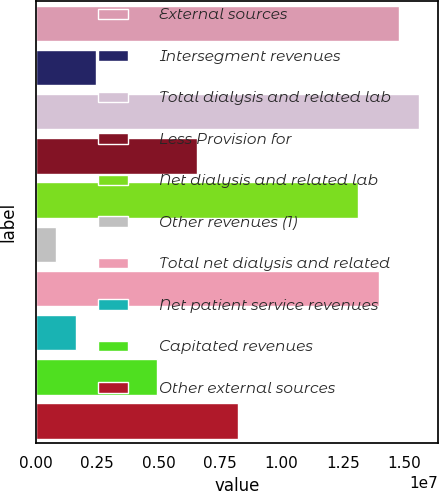Convert chart to OTSL. <chart><loc_0><loc_0><loc_500><loc_500><bar_chart><fcel>External sources<fcel>Intersegment revenues<fcel>Total dialysis and related lab<fcel>Less Provision for<fcel>Net dialysis and related lab<fcel>Other revenues (1)<fcel>Total net dialysis and related<fcel>Net patient service revenues<fcel>Capitated revenues<fcel>Other external sources<nl><fcel>1.47832e+07<fcel>2.46698e+06<fcel>1.56043e+07<fcel>6.57238e+06<fcel>1.3141e+07<fcel>824818<fcel>1.39621e+07<fcel>1.6459e+06<fcel>4.93022e+06<fcel>8.21455e+06<nl></chart> 